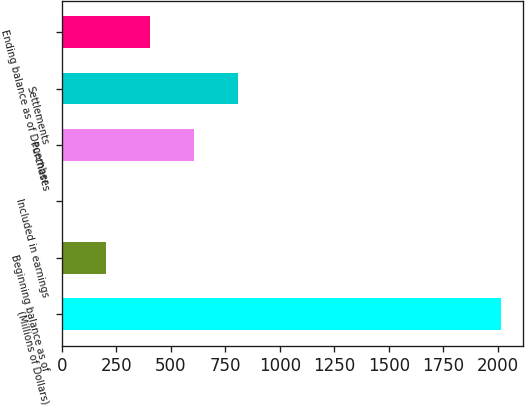<chart> <loc_0><loc_0><loc_500><loc_500><bar_chart><fcel>(Millions of Dollars)<fcel>Beginning balance as of<fcel>Included in earnings<fcel>Purchases<fcel>Settlements<fcel>Ending balance as of December<nl><fcel>2014<fcel>203.2<fcel>2<fcel>605.6<fcel>806.8<fcel>404.4<nl></chart> 